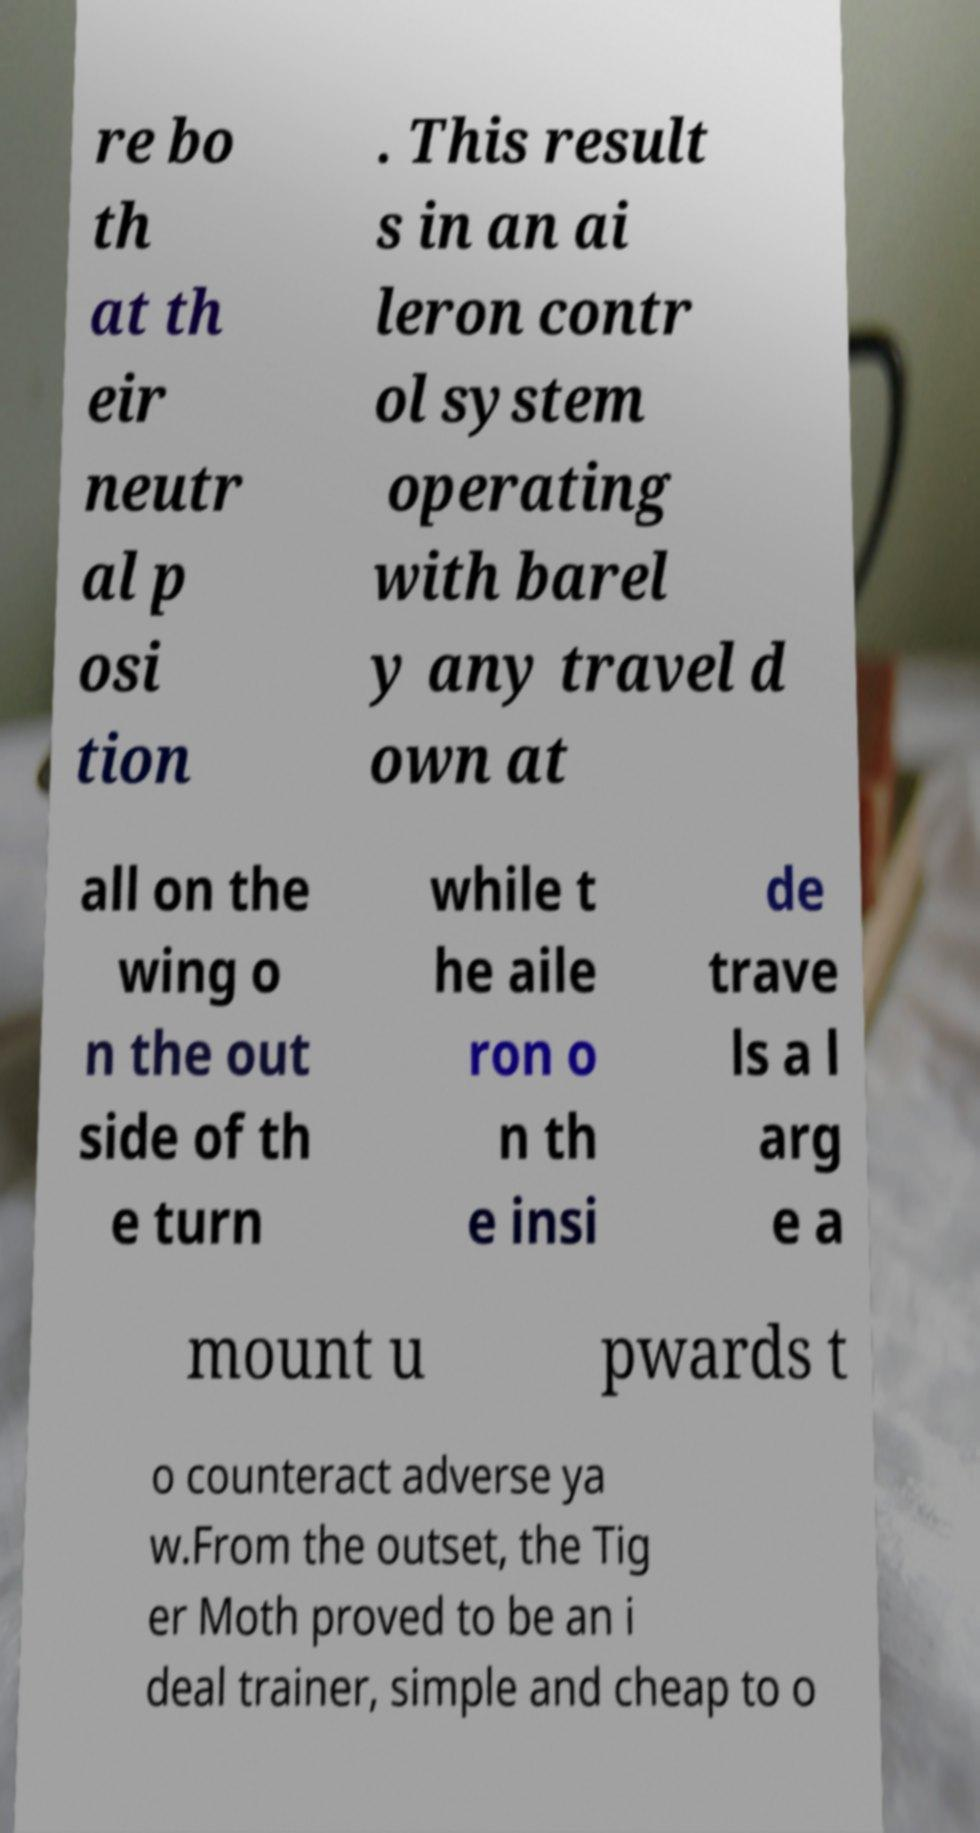Can you accurately transcribe the text from the provided image for me? re bo th at th eir neutr al p osi tion . This result s in an ai leron contr ol system operating with barel y any travel d own at all on the wing o n the out side of th e turn while t he aile ron o n th e insi de trave ls a l arg e a mount u pwards t o counteract adverse ya w.From the outset, the Tig er Moth proved to be an i deal trainer, simple and cheap to o 